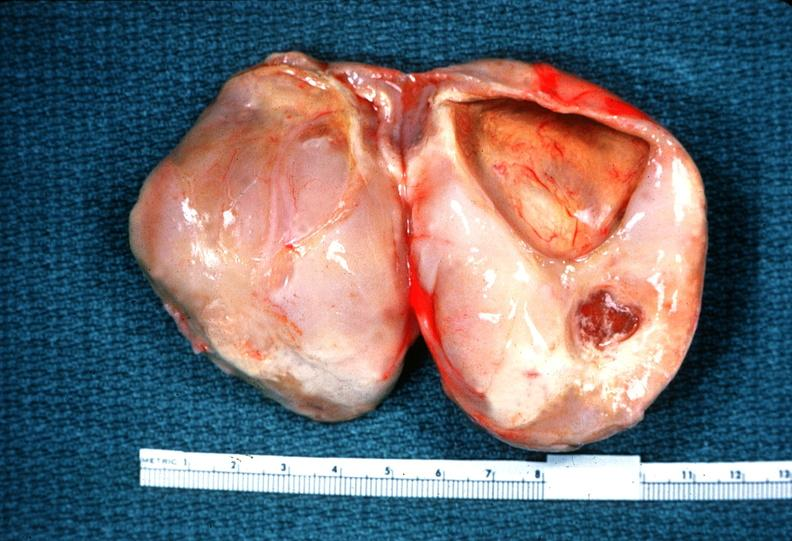s choanal atresia present?
Answer the question using a single word or phrase. No 